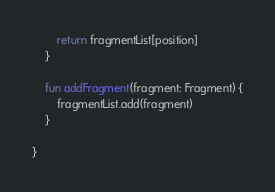Convert code to text. <code><loc_0><loc_0><loc_500><loc_500><_Kotlin_>        return fragmentList[position]
    }

    fun addFragment(fragment: Fragment) {
        fragmentList.add(fragment)
    }

}</code> 